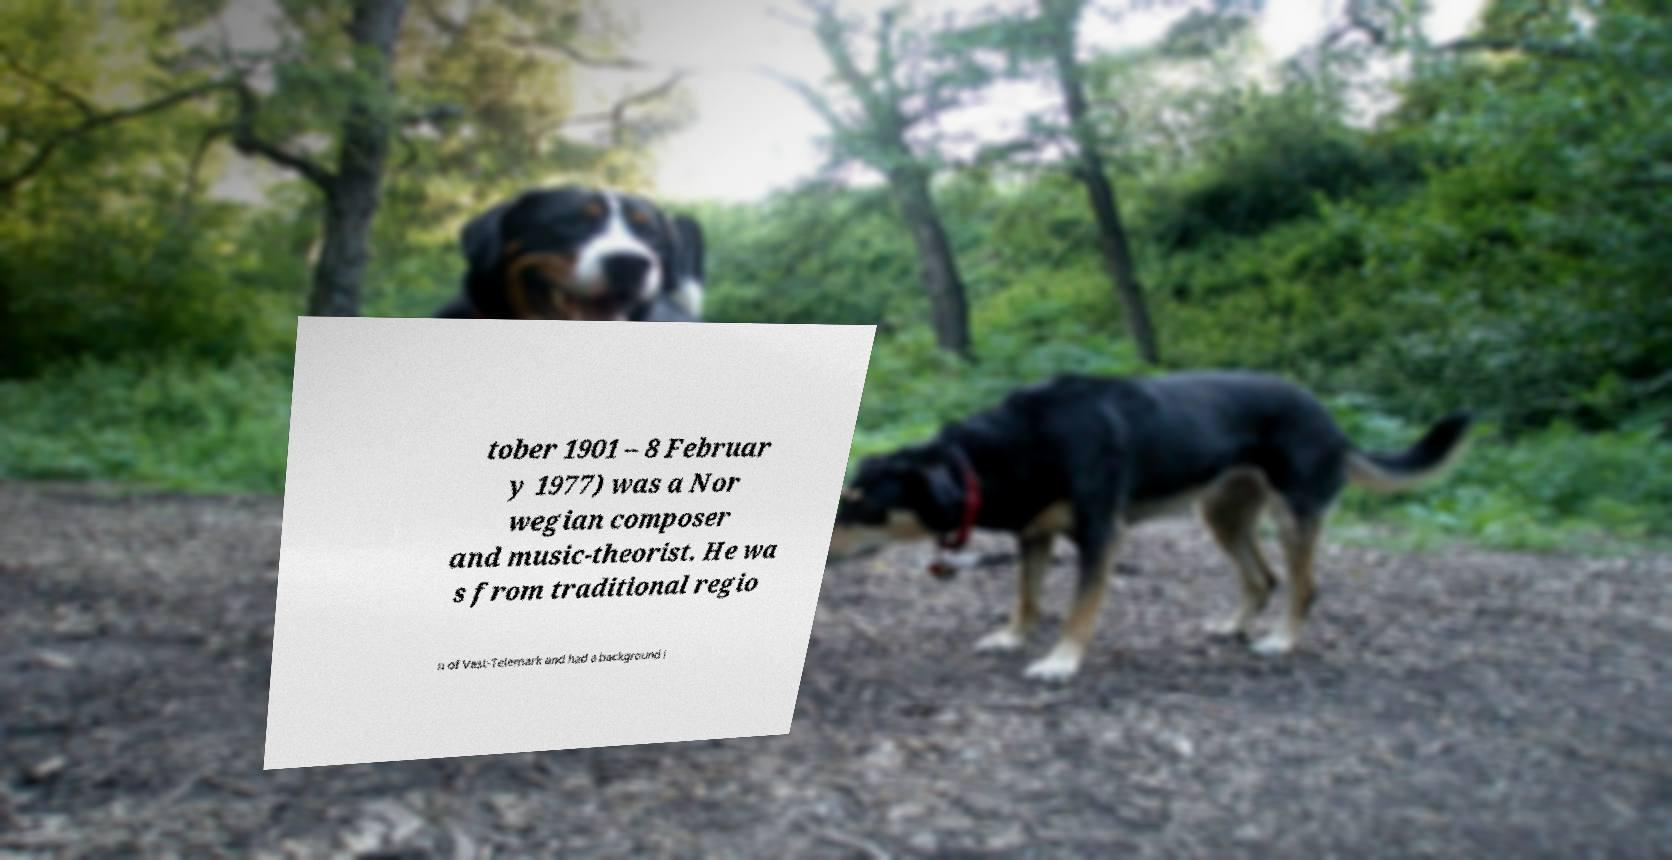I need the written content from this picture converted into text. Can you do that? tober 1901 – 8 Februar y 1977) was a Nor wegian composer and music-theorist. He wa s from traditional regio n of Vest-Telemark and had a background i 